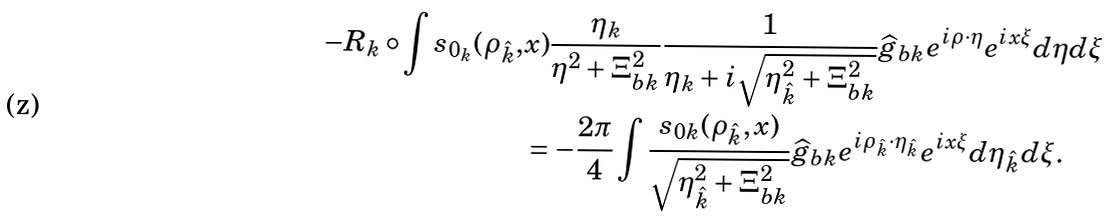<formula> <loc_0><loc_0><loc_500><loc_500>- R _ { k } \circ \int s _ { 0 _ { k } } ( \rho _ { \hat { k } } , & x ) \frac { \eta _ { k } } { \eta ^ { 2 } + \Xi ^ { 2 } _ { b k } } \frac { 1 } { \eta _ { k } + i \sqrt { \eta _ { \hat { k } } ^ { 2 } + \Xi _ { b k } ^ { 2 } } } \widehat { g } _ { b k } e ^ { i \rho \cdot \eta } e ^ { i x \xi } d \eta d \xi \\ & = - \frac { 2 \pi } { 4 } \int \frac { s _ { 0 k } ( \rho _ { \hat { k } } , x ) } { \sqrt { \eta _ { \hat { k } } ^ { 2 } + \Xi _ { b k } ^ { 2 } } } \widehat { g } _ { b k } e ^ { i \rho _ { \hat { k } } \cdot \eta _ { \hat { k } } } e ^ { i x \xi } d \eta _ { \hat { k } } d \xi .</formula> 